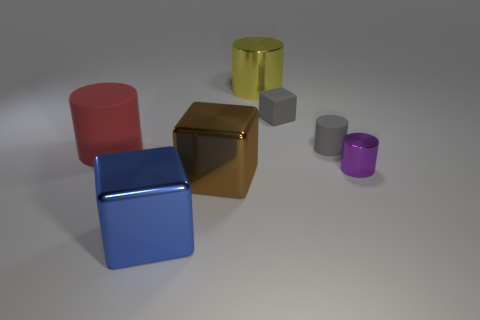Subtract all metallic cubes. How many cubes are left? 1 Add 3 large red matte cylinders. How many objects exist? 10 Subtract 1 cubes. How many cubes are left? 2 Subtract all gray blocks. How many blocks are left? 2 Subtract all purple blocks. Subtract all brown cylinders. How many blocks are left? 3 Subtract all red matte cylinders. Subtract all rubber blocks. How many objects are left? 5 Add 5 small objects. How many small objects are left? 8 Add 4 cylinders. How many cylinders exist? 8 Subtract 0 yellow blocks. How many objects are left? 7 Subtract all cubes. How many objects are left? 4 